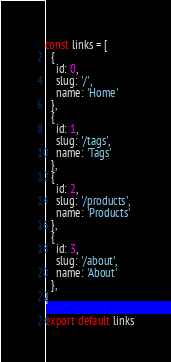<code> <loc_0><loc_0><loc_500><loc_500><_JavaScript_>const links = [
  {
    id: 0,
    slug: '/',
    name: 'Home'
  },
  {
    id: 1,
    slug: '/tags',
    name: 'Tags'
  },
  {
    id: 2,
    slug: '/products',
    name: 'Products'
  },
  {
    id: 3,
    slug: '/about',
    name: 'About'
  },
]

export default links
</code> 